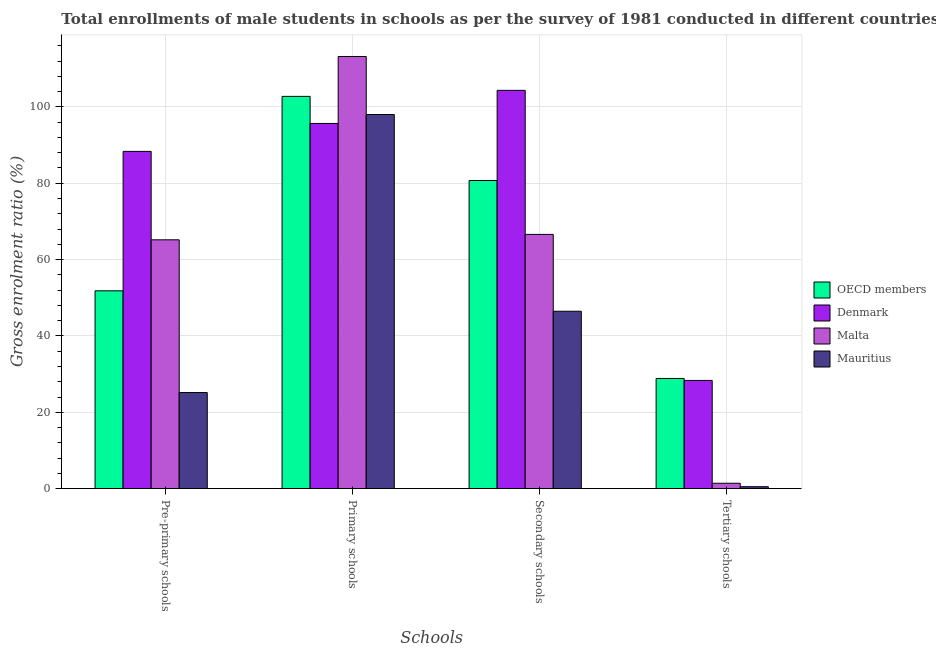How many different coloured bars are there?
Ensure brevity in your answer.  4. Are the number of bars on each tick of the X-axis equal?
Your answer should be very brief. Yes. How many bars are there on the 3rd tick from the right?
Offer a terse response. 4. What is the label of the 2nd group of bars from the left?
Offer a very short reply. Primary schools. What is the gross enrolment ratio(male) in tertiary schools in Malta?
Make the answer very short. 1.42. Across all countries, what is the maximum gross enrolment ratio(male) in tertiary schools?
Offer a terse response. 28.87. Across all countries, what is the minimum gross enrolment ratio(male) in secondary schools?
Give a very brief answer. 46.47. In which country was the gross enrolment ratio(male) in primary schools maximum?
Offer a terse response. Malta. In which country was the gross enrolment ratio(male) in tertiary schools minimum?
Give a very brief answer. Mauritius. What is the total gross enrolment ratio(male) in tertiary schools in the graph?
Give a very brief answer. 59.16. What is the difference between the gross enrolment ratio(male) in pre-primary schools in Denmark and that in OECD members?
Make the answer very short. 36.52. What is the difference between the gross enrolment ratio(male) in tertiary schools in Mauritius and the gross enrolment ratio(male) in primary schools in OECD members?
Offer a terse response. -102.23. What is the average gross enrolment ratio(male) in primary schools per country?
Give a very brief answer. 102.4. What is the difference between the gross enrolment ratio(male) in tertiary schools and gross enrolment ratio(male) in secondary schools in Mauritius?
Offer a terse response. -45.95. In how many countries, is the gross enrolment ratio(male) in pre-primary schools greater than 92 %?
Make the answer very short. 0. What is the ratio of the gross enrolment ratio(male) in pre-primary schools in Malta to that in OECD members?
Provide a succinct answer. 1.26. Is the difference between the gross enrolment ratio(male) in pre-primary schools in Mauritius and Denmark greater than the difference between the gross enrolment ratio(male) in primary schools in Mauritius and Denmark?
Give a very brief answer. No. What is the difference between the highest and the second highest gross enrolment ratio(male) in tertiary schools?
Make the answer very short. 0.51. What is the difference between the highest and the lowest gross enrolment ratio(male) in secondary schools?
Offer a terse response. 57.85. In how many countries, is the gross enrolment ratio(male) in tertiary schools greater than the average gross enrolment ratio(male) in tertiary schools taken over all countries?
Ensure brevity in your answer.  2. What does the 3rd bar from the left in Secondary schools represents?
Offer a very short reply. Malta. What does the 1st bar from the right in Secondary schools represents?
Give a very brief answer. Mauritius. How many bars are there?
Provide a short and direct response. 16. How many countries are there in the graph?
Make the answer very short. 4. What is the difference between two consecutive major ticks on the Y-axis?
Your response must be concise. 20. Are the values on the major ticks of Y-axis written in scientific E-notation?
Give a very brief answer. No. Does the graph contain any zero values?
Offer a very short reply. No. Where does the legend appear in the graph?
Provide a succinct answer. Center right. What is the title of the graph?
Give a very brief answer. Total enrollments of male students in schools as per the survey of 1981 conducted in different countries. What is the label or title of the X-axis?
Make the answer very short. Schools. What is the Gross enrolment ratio (%) of OECD members in Pre-primary schools?
Your answer should be very brief. 51.82. What is the Gross enrolment ratio (%) of Denmark in Pre-primary schools?
Offer a terse response. 88.34. What is the Gross enrolment ratio (%) of Malta in Pre-primary schools?
Provide a short and direct response. 65.18. What is the Gross enrolment ratio (%) of Mauritius in Pre-primary schools?
Your answer should be very brief. 25.18. What is the Gross enrolment ratio (%) in OECD members in Primary schools?
Your answer should be compact. 102.75. What is the Gross enrolment ratio (%) in Denmark in Primary schools?
Offer a terse response. 95.66. What is the Gross enrolment ratio (%) in Malta in Primary schools?
Your answer should be very brief. 113.2. What is the Gross enrolment ratio (%) in Mauritius in Primary schools?
Provide a short and direct response. 98. What is the Gross enrolment ratio (%) in OECD members in Secondary schools?
Offer a very short reply. 80.71. What is the Gross enrolment ratio (%) of Denmark in Secondary schools?
Provide a short and direct response. 104.33. What is the Gross enrolment ratio (%) of Malta in Secondary schools?
Provide a succinct answer. 66.6. What is the Gross enrolment ratio (%) in Mauritius in Secondary schools?
Your answer should be very brief. 46.47. What is the Gross enrolment ratio (%) of OECD members in Tertiary schools?
Keep it short and to the point. 28.87. What is the Gross enrolment ratio (%) in Denmark in Tertiary schools?
Your answer should be very brief. 28.36. What is the Gross enrolment ratio (%) in Malta in Tertiary schools?
Provide a succinct answer. 1.42. What is the Gross enrolment ratio (%) of Mauritius in Tertiary schools?
Your response must be concise. 0.52. Across all Schools, what is the maximum Gross enrolment ratio (%) of OECD members?
Offer a terse response. 102.75. Across all Schools, what is the maximum Gross enrolment ratio (%) of Denmark?
Your answer should be very brief. 104.33. Across all Schools, what is the maximum Gross enrolment ratio (%) of Malta?
Provide a succinct answer. 113.2. Across all Schools, what is the maximum Gross enrolment ratio (%) of Mauritius?
Offer a very short reply. 98. Across all Schools, what is the minimum Gross enrolment ratio (%) in OECD members?
Offer a terse response. 28.87. Across all Schools, what is the minimum Gross enrolment ratio (%) in Denmark?
Offer a very short reply. 28.36. Across all Schools, what is the minimum Gross enrolment ratio (%) in Malta?
Keep it short and to the point. 1.42. Across all Schools, what is the minimum Gross enrolment ratio (%) in Mauritius?
Provide a short and direct response. 0.52. What is the total Gross enrolment ratio (%) of OECD members in the graph?
Provide a short and direct response. 264.15. What is the total Gross enrolment ratio (%) in Denmark in the graph?
Your response must be concise. 316.69. What is the total Gross enrolment ratio (%) in Malta in the graph?
Ensure brevity in your answer.  246.4. What is the total Gross enrolment ratio (%) in Mauritius in the graph?
Ensure brevity in your answer.  170.17. What is the difference between the Gross enrolment ratio (%) in OECD members in Pre-primary schools and that in Primary schools?
Ensure brevity in your answer.  -50.92. What is the difference between the Gross enrolment ratio (%) in Denmark in Pre-primary schools and that in Primary schools?
Offer a terse response. -7.31. What is the difference between the Gross enrolment ratio (%) in Malta in Pre-primary schools and that in Primary schools?
Your answer should be compact. -48.02. What is the difference between the Gross enrolment ratio (%) in Mauritius in Pre-primary schools and that in Primary schools?
Offer a terse response. -72.82. What is the difference between the Gross enrolment ratio (%) of OECD members in Pre-primary schools and that in Secondary schools?
Ensure brevity in your answer.  -28.89. What is the difference between the Gross enrolment ratio (%) in Denmark in Pre-primary schools and that in Secondary schools?
Offer a terse response. -15.98. What is the difference between the Gross enrolment ratio (%) of Malta in Pre-primary schools and that in Secondary schools?
Make the answer very short. -1.42. What is the difference between the Gross enrolment ratio (%) of Mauritius in Pre-primary schools and that in Secondary schools?
Make the answer very short. -21.3. What is the difference between the Gross enrolment ratio (%) of OECD members in Pre-primary schools and that in Tertiary schools?
Make the answer very short. 22.96. What is the difference between the Gross enrolment ratio (%) in Denmark in Pre-primary schools and that in Tertiary schools?
Your response must be concise. 59.99. What is the difference between the Gross enrolment ratio (%) in Malta in Pre-primary schools and that in Tertiary schools?
Make the answer very short. 63.76. What is the difference between the Gross enrolment ratio (%) of Mauritius in Pre-primary schools and that in Tertiary schools?
Keep it short and to the point. 24.66. What is the difference between the Gross enrolment ratio (%) of OECD members in Primary schools and that in Secondary schools?
Ensure brevity in your answer.  22.03. What is the difference between the Gross enrolment ratio (%) in Denmark in Primary schools and that in Secondary schools?
Offer a very short reply. -8.67. What is the difference between the Gross enrolment ratio (%) in Malta in Primary schools and that in Secondary schools?
Provide a succinct answer. 46.6. What is the difference between the Gross enrolment ratio (%) in Mauritius in Primary schools and that in Secondary schools?
Offer a very short reply. 51.53. What is the difference between the Gross enrolment ratio (%) of OECD members in Primary schools and that in Tertiary schools?
Keep it short and to the point. 73.88. What is the difference between the Gross enrolment ratio (%) of Denmark in Primary schools and that in Tertiary schools?
Your answer should be very brief. 67.3. What is the difference between the Gross enrolment ratio (%) of Malta in Primary schools and that in Tertiary schools?
Make the answer very short. 111.78. What is the difference between the Gross enrolment ratio (%) in Mauritius in Primary schools and that in Tertiary schools?
Keep it short and to the point. 97.48. What is the difference between the Gross enrolment ratio (%) in OECD members in Secondary schools and that in Tertiary schools?
Your response must be concise. 51.85. What is the difference between the Gross enrolment ratio (%) in Denmark in Secondary schools and that in Tertiary schools?
Give a very brief answer. 75.97. What is the difference between the Gross enrolment ratio (%) of Malta in Secondary schools and that in Tertiary schools?
Provide a short and direct response. 65.18. What is the difference between the Gross enrolment ratio (%) of Mauritius in Secondary schools and that in Tertiary schools?
Offer a terse response. 45.95. What is the difference between the Gross enrolment ratio (%) in OECD members in Pre-primary schools and the Gross enrolment ratio (%) in Denmark in Primary schools?
Provide a succinct answer. -43.83. What is the difference between the Gross enrolment ratio (%) of OECD members in Pre-primary schools and the Gross enrolment ratio (%) of Malta in Primary schools?
Your response must be concise. -61.38. What is the difference between the Gross enrolment ratio (%) in OECD members in Pre-primary schools and the Gross enrolment ratio (%) in Mauritius in Primary schools?
Keep it short and to the point. -46.17. What is the difference between the Gross enrolment ratio (%) of Denmark in Pre-primary schools and the Gross enrolment ratio (%) of Malta in Primary schools?
Provide a short and direct response. -24.85. What is the difference between the Gross enrolment ratio (%) of Denmark in Pre-primary schools and the Gross enrolment ratio (%) of Mauritius in Primary schools?
Give a very brief answer. -9.65. What is the difference between the Gross enrolment ratio (%) of Malta in Pre-primary schools and the Gross enrolment ratio (%) of Mauritius in Primary schools?
Your answer should be compact. -32.82. What is the difference between the Gross enrolment ratio (%) of OECD members in Pre-primary schools and the Gross enrolment ratio (%) of Denmark in Secondary schools?
Your answer should be compact. -52.5. What is the difference between the Gross enrolment ratio (%) of OECD members in Pre-primary schools and the Gross enrolment ratio (%) of Malta in Secondary schools?
Give a very brief answer. -14.78. What is the difference between the Gross enrolment ratio (%) in OECD members in Pre-primary schools and the Gross enrolment ratio (%) in Mauritius in Secondary schools?
Your answer should be very brief. 5.35. What is the difference between the Gross enrolment ratio (%) in Denmark in Pre-primary schools and the Gross enrolment ratio (%) in Malta in Secondary schools?
Provide a succinct answer. 21.74. What is the difference between the Gross enrolment ratio (%) in Denmark in Pre-primary schools and the Gross enrolment ratio (%) in Mauritius in Secondary schools?
Keep it short and to the point. 41.87. What is the difference between the Gross enrolment ratio (%) of Malta in Pre-primary schools and the Gross enrolment ratio (%) of Mauritius in Secondary schools?
Your response must be concise. 18.71. What is the difference between the Gross enrolment ratio (%) of OECD members in Pre-primary schools and the Gross enrolment ratio (%) of Denmark in Tertiary schools?
Offer a very short reply. 23.47. What is the difference between the Gross enrolment ratio (%) in OECD members in Pre-primary schools and the Gross enrolment ratio (%) in Malta in Tertiary schools?
Your answer should be very brief. 50.41. What is the difference between the Gross enrolment ratio (%) in OECD members in Pre-primary schools and the Gross enrolment ratio (%) in Mauritius in Tertiary schools?
Provide a succinct answer. 51.3. What is the difference between the Gross enrolment ratio (%) of Denmark in Pre-primary schools and the Gross enrolment ratio (%) of Malta in Tertiary schools?
Your response must be concise. 86.93. What is the difference between the Gross enrolment ratio (%) of Denmark in Pre-primary schools and the Gross enrolment ratio (%) of Mauritius in Tertiary schools?
Your answer should be very brief. 87.82. What is the difference between the Gross enrolment ratio (%) in Malta in Pre-primary schools and the Gross enrolment ratio (%) in Mauritius in Tertiary schools?
Offer a very short reply. 64.66. What is the difference between the Gross enrolment ratio (%) of OECD members in Primary schools and the Gross enrolment ratio (%) of Denmark in Secondary schools?
Give a very brief answer. -1.58. What is the difference between the Gross enrolment ratio (%) of OECD members in Primary schools and the Gross enrolment ratio (%) of Malta in Secondary schools?
Ensure brevity in your answer.  36.15. What is the difference between the Gross enrolment ratio (%) of OECD members in Primary schools and the Gross enrolment ratio (%) of Mauritius in Secondary schools?
Provide a short and direct response. 56.27. What is the difference between the Gross enrolment ratio (%) in Denmark in Primary schools and the Gross enrolment ratio (%) in Malta in Secondary schools?
Provide a short and direct response. 29.06. What is the difference between the Gross enrolment ratio (%) of Denmark in Primary schools and the Gross enrolment ratio (%) of Mauritius in Secondary schools?
Provide a short and direct response. 49.19. What is the difference between the Gross enrolment ratio (%) of Malta in Primary schools and the Gross enrolment ratio (%) of Mauritius in Secondary schools?
Give a very brief answer. 66.73. What is the difference between the Gross enrolment ratio (%) of OECD members in Primary schools and the Gross enrolment ratio (%) of Denmark in Tertiary schools?
Ensure brevity in your answer.  74.39. What is the difference between the Gross enrolment ratio (%) of OECD members in Primary schools and the Gross enrolment ratio (%) of Malta in Tertiary schools?
Make the answer very short. 101.33. What is the difference between the Gross enrolment ratio (%) of OECD members in Primary schools and the Gross enrolment ratio (%) of Mauritius in Tertiary schools?
Provide a short and direct response. 102.23. What is the difference between the Gross enrolment ratio (%) in Denmark in Primary schools and the Gross enrolment ratio (%) in Malta in Tertiary schools?
Ensure brevity in your answer.  94.24. What is the difference between the Gross enrolment ratio (%) in Denmark in Primary schools and the Gross enrolment ratio (%) in Mauritius in Tertiary schools?
Ensure brevity in your answer.  95.14. What is the difference between the Gross enrolment ratio (%) of Malta in Primary schools and the Gross enrolment ratio (%) of Mauritius in Tertiary schools?
Provide a short and direct response. 112.68. What is the difference between the Gross enrolment ratio (%) in OECD members in Secondary schools and the Gross enrolment ratio (%) in Denmark in Tertiary schools?
Offer a very short reply. 52.36. What is the difference between the Gross enrolment ratio (%) in OECD members in Secondary schools and the Gross enrolment ratio (%) in Malta in Tertiary schools?
Give a very brief answer. 79.3. What is the difference between the Gross enrolment ratio (%) of OECD members in Secondary schools and the Gross enrolment ratio (%) of Mauritius in Tertiary schools?
Offer a very short reply. 80.19. What is the difference between the Gross enrolment ratio (%) in Denmark in Secondary schools and the Gross enrolment ratio (%) in Malta in Tertiary schools?
Your response must be concise. 102.91. What is the difference between the Gross enrolment ratio (%) of Denmark in Secondary schools and the Gross enrolment ratio (%) of Mauritius in Tertiary schools?
Offer a terse response. 103.81. What is the difference between the Gross enrolment ratio (%) of Malta in Secondary schools and the Gross enrolment ratio (%) of Mauritius in Tertiary schools?
Offer a terse response. 66.08. What is the average Gross enrolment ratio (%) in OECD members per Schools?
Make the answer very short. 66.04. What is the average Gross enrolment ratio (%) in Denmark per Schools?
Your response must be concise. 79.17. What is the average Gross enrolment ratio (%) of Malta per Schools?
Make the answer very short. 61.6. What is the average Gross enrolment ratio (%) in Mauritius per Schools?
Provide a short and direct response. 42.54. What is the difference between the Gross enrolment ratio (%) of OECD members and Gross enrolment ratio (%) of Denmark in Pre-primary schools?
Your answer should be very brief. -36.52. What is the difference between the Gross enrolment ratio (%) in OECD members and Gross enrolment ratio (%) in Malta in Pre-primary schools?
Your answer should be compact. -13.36. What is the difference between the Gross enrolment ratio (%) in OECD members and Gross enrolment ratio (%) in Mauritius in Pre-primary schools?
Ensure brevity in your answer.  26.65. What is the difference between the Gross enrolment ratio (%) of Denmark and Gross enrolment ratio (%) of Malta in Pre-primary schools?
Ensure brevity in your answer.  23.16. What is the difference between the Gross enrolment ratio (%) of Denmark and Gross enrolment ratio (%) of Mauritius in Pre-primary schools?
Provide a short and direct response. 63.17. What is the difference between the Gross enrolment ratio (%) in Malta and Gross enrolment ratio (%) in Mauritius in Pre-primary schools?
Provide a short and direct response. 40. What is the difference between the Gross enrolment ratio (%) in OECD members and Gross enrolment ratio (%) in Denmark in Primary schools?
Ensure brevity in your answer.  7.09. What is the difference between the Gross enrolment ratio (%) in OECD members and Gross enrolment ratio (%) in Malta in Primary schools?
Your answer should be very brief. -10.45. What is the difference between the Gross enrolment ratio (%) of OECD members and Gross enrolment ratio (%) of Mauritius in Primary schools?
Keep it short and to the point. 4.75. What is the difference between the Gross enrolment ratio (%) of Denmark and Gross enrolment ratio (%) of Malta in Primary schools?
Keep it short and to the point. -17.54. What is the difference between the Gross enrolment ratio (%) of Denmark and Gross enrolment ratio (%) of Mauritius in Primary schools?
Provide a short and direct response. -2.34. What is the difference between the Gross enrolment ratio (%) in Malta and Gross enrolment ratio (%) in Mauritius in Primary schools?
Give a very brief answer. 15.2. What is the difference between the Gross enrolment ratio (%) in OECD members and Gross enrolment ratio (%) in Denmark in Secondary schools?
Make the answer very short. -23.61. What is the difference between the Gross enrolment ratio (%) of OECD members and Gross enrolment ratio (%) of Malta in Secondary schools?
Give a very brief answer. 14.11. What is the difference between the Gross enrolment ratio (%) of OECD members and Gross enrolment ratio (%) of Mauritius in Secondary schools?
Offer a terse response. 34.24. What is the difference between the Gross enrolment ratio (%) of Denmark and Gross enrolment ratio (%) of Malta in Secondary schools?
Keep it short and to the point. 37.73. What is the difference between the Gross enrolment ratio (%) in Denmark and Gross enrolment ratio (%) in Mauritius in Secondary schools?
Keep it short and to the point. 57.85. What is the difference between the Gross enrolment ratio (%) in Malta and Gross enrolment ratio (%) in Mauritius in Secondary schools?
Make the answer very short. 20.13. What is the difference between the Gross enrolment ratio (%) of OECD members and Gross enrolment ratio (%) of Denmark in Tertiary schools?
Your answer should be compact. 0.51. What is the difference between the Gross enrolment ratio (%) of OECD members and Gross enrolment ratio (%) of Malta in Tertiary schools?
Ensure brevity in your answer.  27.45. What is the difference between the Gross enrolment ratio (%) of OECD members and Gross enrolment ratio (%) of Mauritius in Tertiary schools?
Offer a terse response. 28.35. What is the difference between the Gross enrolment ratio (%) in Denmark and Gross enrolment ratio (%) in Malta in Tertiary schools?
Your answer should be compact. 26.94. What is the difference between the Gross enrolment ratio (%) of Denmark and Gross enrolment ratio (%) of Mauritius in Tertiary schools?
Your response must be concise. 27.84. What is the difference between the Gross enrolment ratio (%) in Malta and Gross enrolment ratio (%) in Mauritius in Tertiary schools?
Your answer should be very brief. 0.9. What is the ratio of the Gross enrolment ratio (%) in OECD members in Pre-primary schools to that in Primary schools?
Offer a terse response. 0.5. What is the ratio of the Gross enrolment ratio (%) in Denmark in Pre-primary schools to that in Primary schools?
Make the answer very short. 0.92. What is the ratio of the Gross enrolment ratio (%) of Malta in Pre-primary schools to that in Primary schools?
Offer a terse response. 0.58. What is the ratio of the Gross enrolment ratio (%) of Mauritius in Pre-primary schools to that in Primary schools?
Your response must be concise. 0.26. What is the ratio of the Gross enrolment ratio (%) in OECD members in Pre-primary schools to that in Secondary schools?
Give a very brief answer. 0.64. What is the ratio of the Gross enrolment ratio (%) in Denmark in Pre-primary schools to that in Secondary schools?
Keep it short and to the point. 0.85. What is the ratio of the Gross enrolment ratio (%) of Malta in Pre-primary schools to that in Secondary schools?
Provide a succinct answer. 0.98. What is the ratio of the Gross enrolment ratio (%) of Mauritius in Pre-primary schools to that in Secondary schools?
Provide a succinct answer. 0.54. What is the ratio of the Gross enrolment ratio (%) in OECD members in Pre-primary schools to that in Tertiary schools?
Your answer should be compact. 1.8. What is the ratio of the Gross enrolment ratio (%) of Denmark in Pre-primary schools to that in Tertiary schools?
Provide a short and direct response. 3.12. What is the ratio of the Gross enrolment ratio (%) in Malta in Pre-primary schools to that in Tertiary schools?
Keep it short and to the point. 45.96. What is the ratio of the Gross enrolment ratio (%) of Mauritius in Pre-primary schools to that in Tertiary schools?
Your answer should be very brief. 48.39. What is the ratio of the Gross enrolment ratio (%) of OECD members in Primary schools to that in Secondary schools?
Your answer should be compact. 1.27. What is the ratio of the Gross enrolment ratio (%) of Denmark in Primary schools to that in Secondary schools?
Keep it short and to the point. 0.92. What is the ratio of the Gross enrolment ratio (%) in Malta in Primary schools to that in Secondary schools?
Your response must be concise. 1.7. What is the ratio of the Gross enrolment ratio (%) in Mauritius in Primary schools to that in Secondary schools?
Provide a succinct answer. 2.11. What is the ratio of the Gross enrolment ratio (%) of OECD members in Primary schools to that in Tertiary schools?
Your answer should be compact. 3.56. What is the ratio of the Gross enrolment ratio (%) of Denmark in Primary schools to that in Tertiary schools?
Provide a succinct answer. 3.37. What is the ratio of the Gross enrolment ratio (%) of Malta in Primary schools to that in Tertiary schools?
Offer a terse response. 79.82. What is the ratio of the Gross enrolment ratio (%) in Mauritius in Primary schools to that in Tertiary schools?
Your response must be concise. 188.33. What is the ratio of the Gross enrolment ratio (%) of OECD members in Secondary schools to that in Tertiary schools?
Provide a short and direct response. 2.8. What is the ratio of the Gross enrolment ratio (%) of Denmark in Secondary schools to that in Tertiary schools?
Your response must be concise. 3.68. What is the ratio of the Gross enrolment ratio (%) of Malta in Secondary schools to that in Tertiary schools?
Your response must be concise. 46.96. What is the ratio of the Gross enrolment ratio (%) in Mauritius in Secondary schools to that in Tertiary schools?
Your response must be concise. 89.31. What is the difference between the highest and the second highest Gross enrolment ratio (%) of OECD members?
Your answer should be very brief. 22.03. What is the difference between the highest and the second highest Gross enrolment ratio (%) of Denmark?
Provide a short and direct response. 8.67. What is the difference between the highest and the second highest Gross enrolment ratio (%) in Malta?
Your answer should be very brief. 46.6. What is the difference between the highest and the second highest Gross enrolment ratio (%) in Mauritius?
Offer a terse response. 51.53. What is the difference between the highest and the lowest Gross enrolment ratio (%) in OECD members?
Offer a very short reply. 73.88. What is the difference between the highest and the lowest Gross enrolment ratio (%) of Denmark?
Provide a short and direct response. 75.97. What is the difference between the highest and the lowest Gross enrolment ratio (%) in Malta?
Ensure brevity in your answer.  111.78. What is the difference between the highest and the lowest Gross enrolment ratio (%) of Mauritius?
Your answer should be compact. 97.48. 